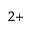Convert formula to latex. <formula><loc_0><loc_0><loc_500><loc_500>^ { 2 + }</formula> 